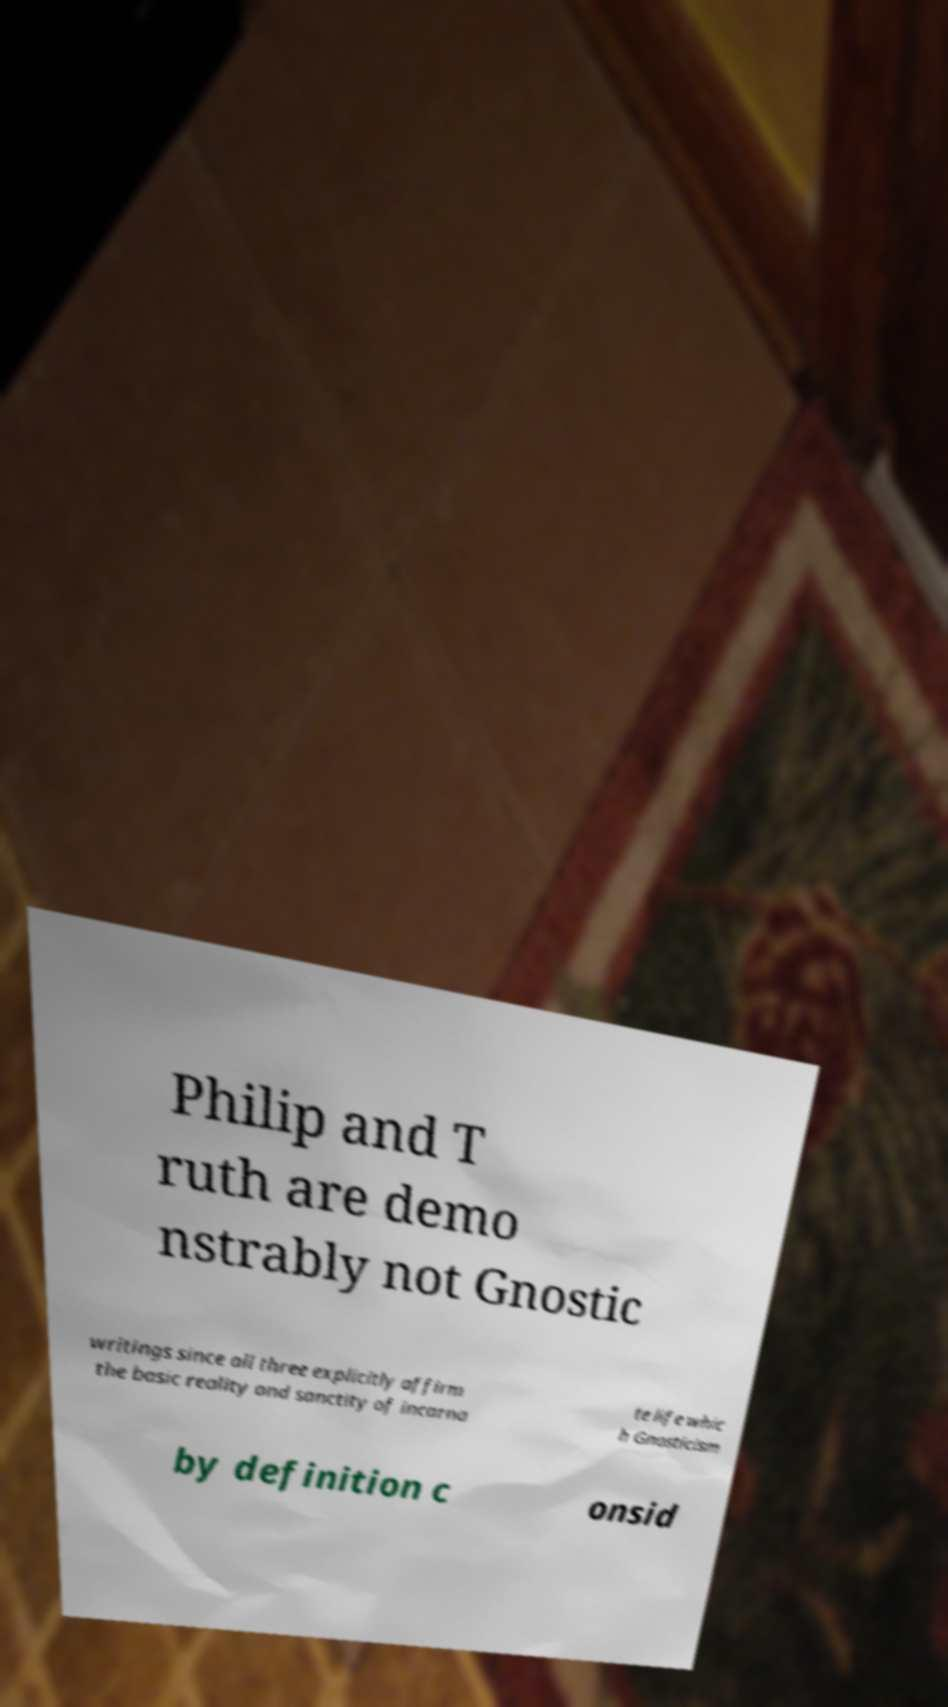Please identify and transcribe the text found in this image. Philip and T ruth are demo nstrably not Gnostic writings since all three explicitly affirm the basic reality and sanctity of incarna te life whic h Gnosticism by definition c onsid 